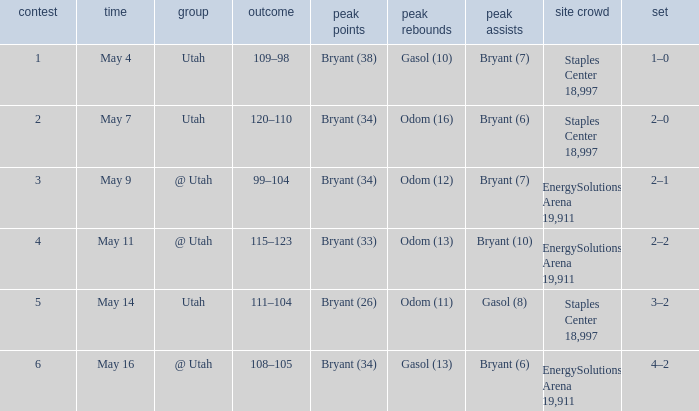What is the High rebounds with a Series with 4–2? Gasol (13). 